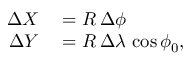<formula> <loc_0><loc_0><loc_500><loc_500>\begin{array} { r l } { \Delta X } & = R \, \Delta \phi } \\ { \Delta Y } & = R \, \Delta \lambda \, \cos { \phi _ { 0 } } , } \end{array}</formula> 